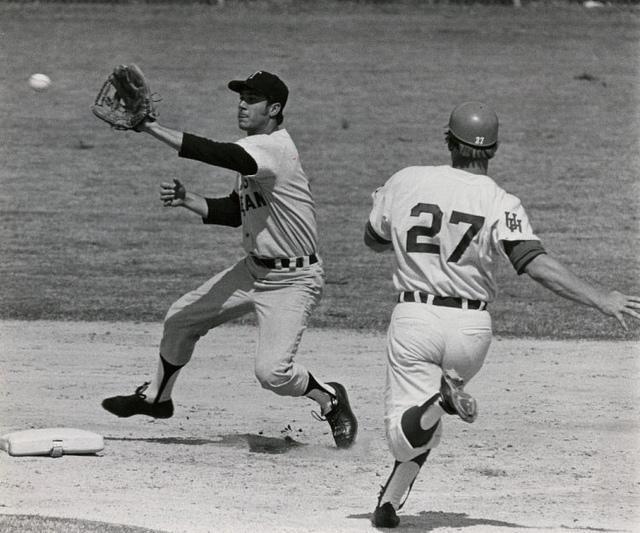How many players are in the picture?
Give a very brief answer. 2. How many people can be seen?
Give a very brief answer. 2. How many plastic white forks can you count?
Give a very brief answer. 0. 